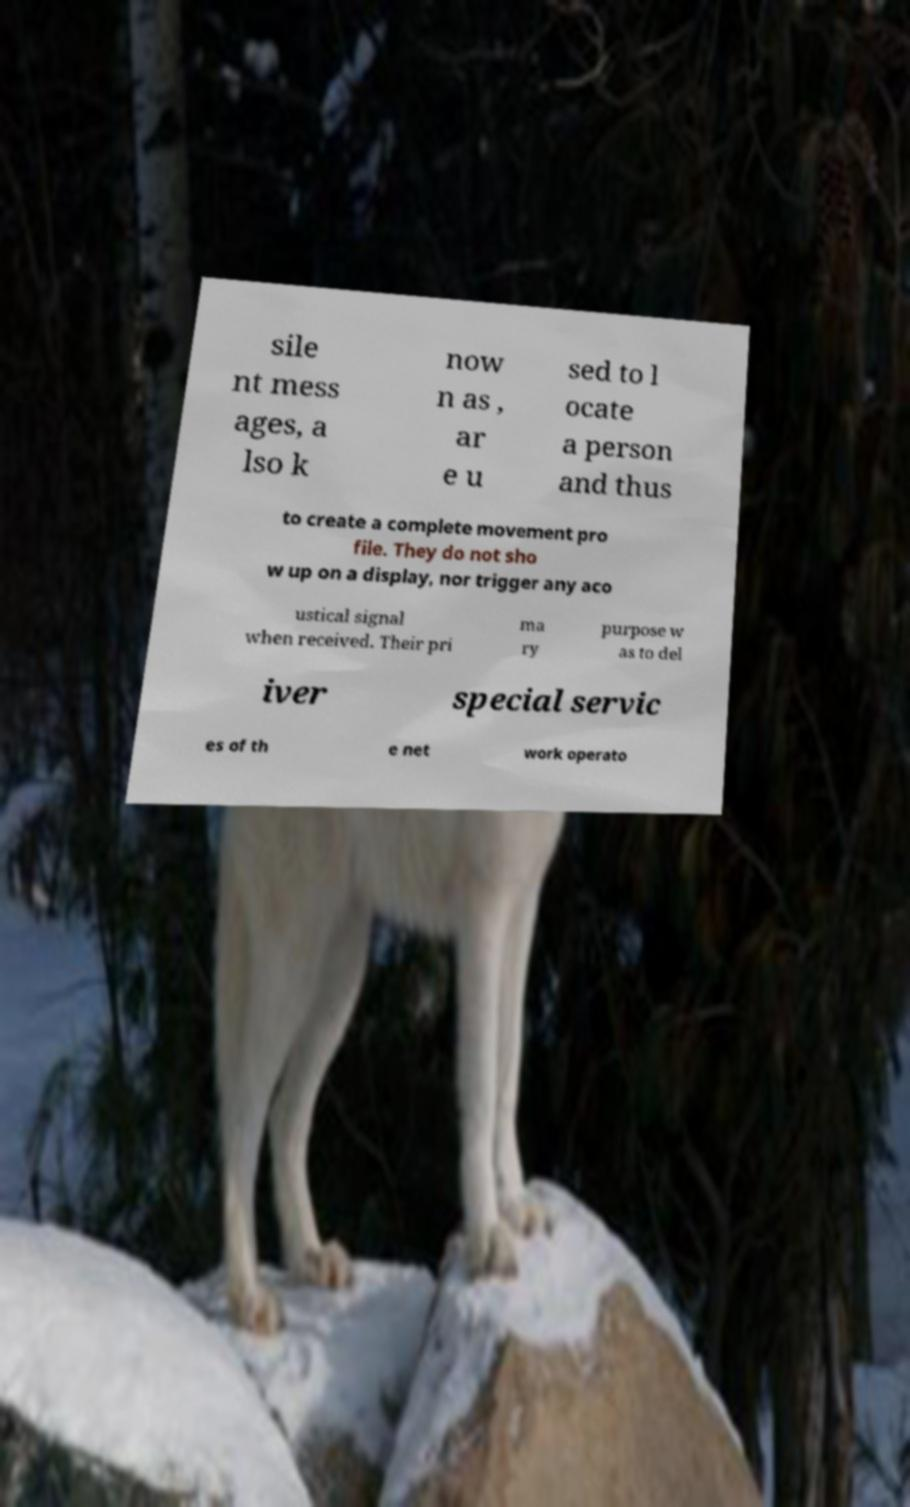Could you extract and type out the text from this image? sile nt mess ages, a lso k now n as , ar e u sed to l ocate a person and thus to create a complete movement pro file. They do not sho w up on a display, nor trigger any aco ustical signal when received. Their pri ma ry purpose w as to del iver special servic es of th e net work operato 